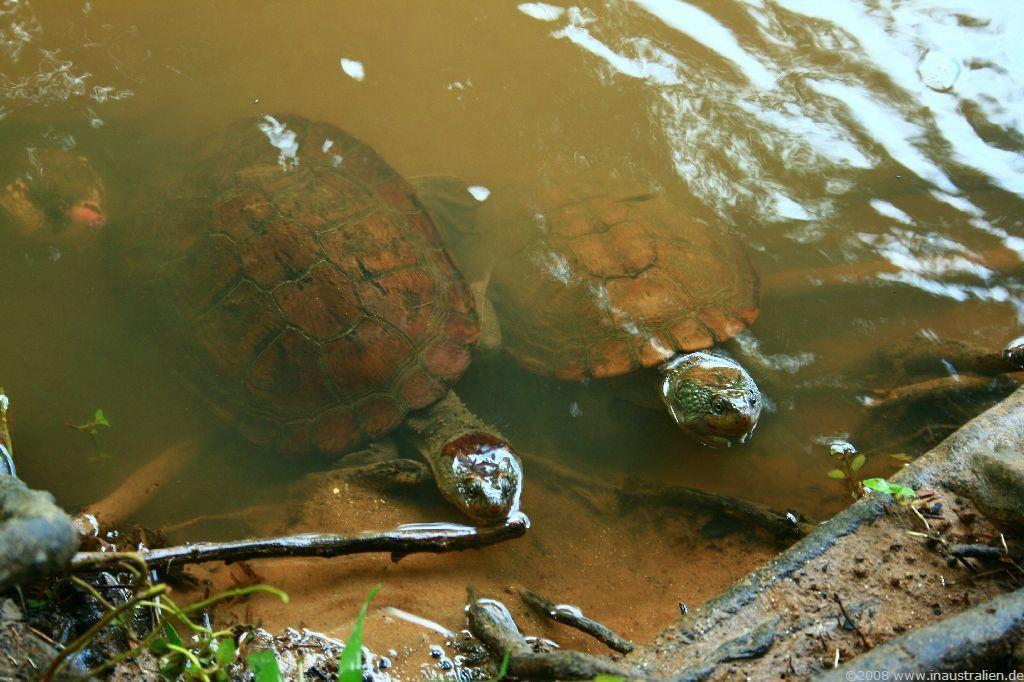How many turtles are in the image? There are two turtles in the image. Where are the turtles located? The turtles are in water. Can you describe the possible location of the water? The water might be in a pond. What can be seen at the bottom of the image? There are twigs visible at the bottom of the image. What are the turtles using their hands to do in the image? Turtles do not have hands, so they cannot be seen doing anything with them in the image. 